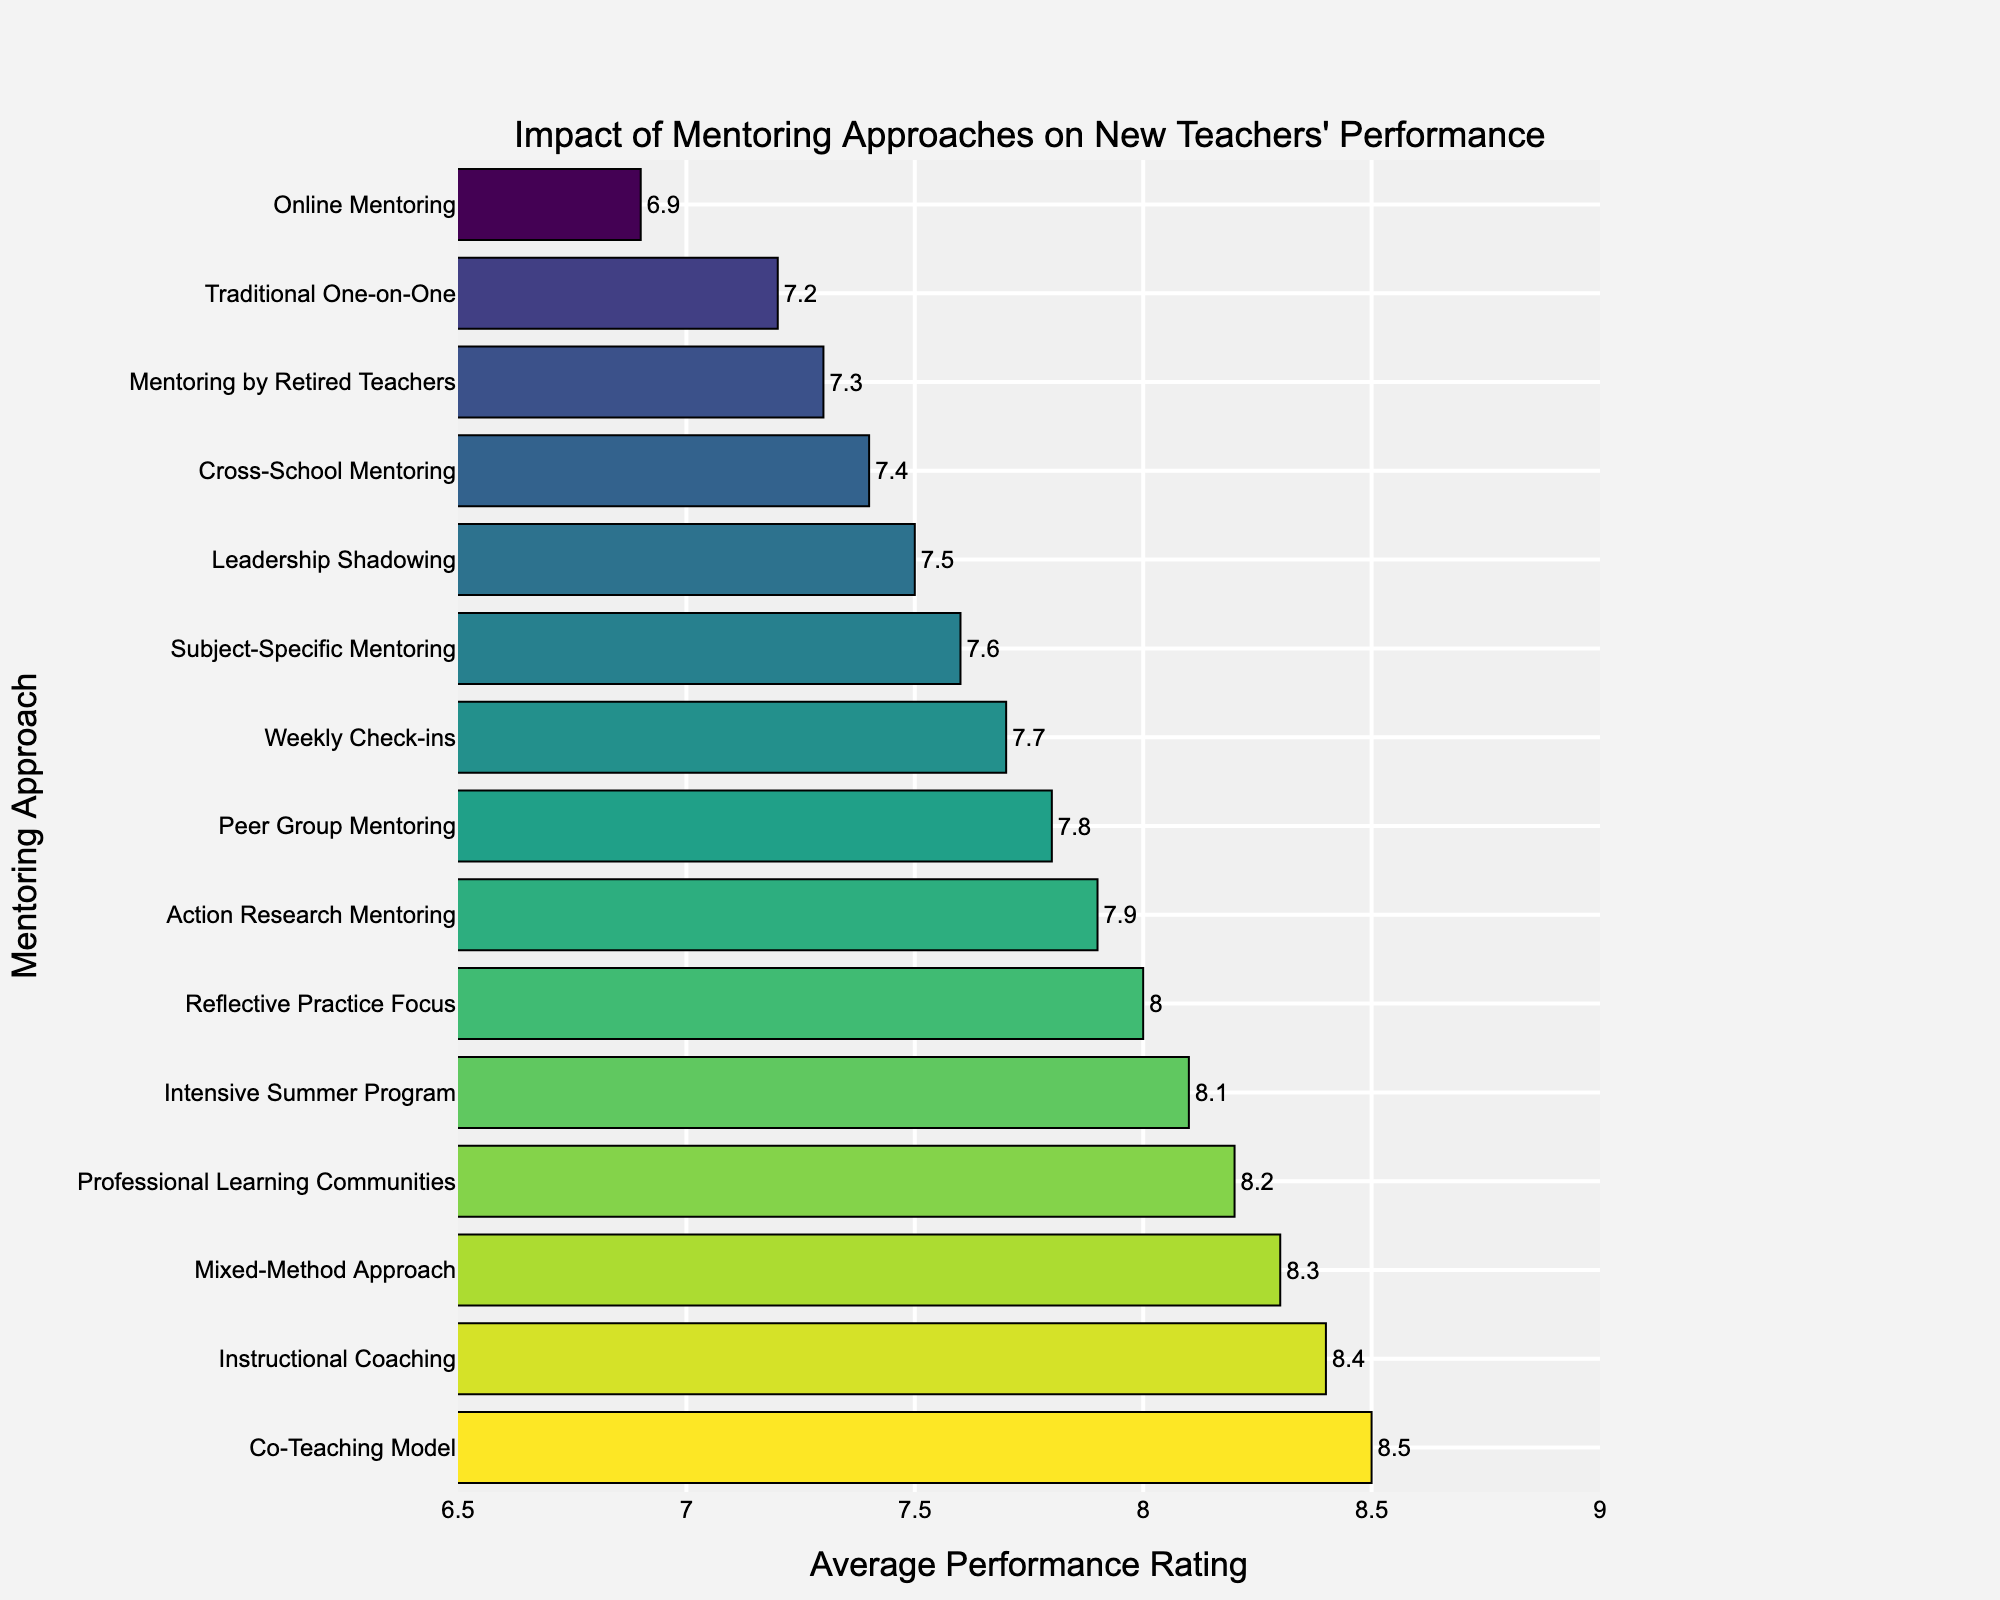Which mentoring approach has the highest average performance rating? The highest bar in the chart corresponds to the mentoring approach with the highest average performance rating. Identify this bar.
Answer: Co-Teaching Model What is the difference in average performance rating between the Co-Teaching Model and Online Mentoring? Find the bar heights for Co-Teaching Model (8.5) and Online Mentoring (6.9). Subtract the smaller from the larger rating.
Answer: 1.6 Which mentoring approaches have an average performance rating greater than 8.0? Look for the bars with heights above the 8.0 mark and list their corresponding mentoring approaches.
Answer: Mixed-Method Approach, Intensive Summer Program, Professional Learning Communities, Instructional Coaching, Co-Teaching Model How many mentoring approaches have an average performance rating less than 7.5? Count the number of bars that do not exceed the 7.5 mark.
Answer: Three What's the combined average performance rating of Instructional Coaching, Mixed-Method Approach, and Professional Learning Communities? Sum the performance ratings of the three approaches (8.4 + 8.3 + 8.2).
Answer: 24.9 Which mentoring approach appears visually midway down the sorted chart and what is its average performance rating? The midpoint in a sorted bar chart with 15 approaches is the 8th bar from the top. Identify this bar and its label.
Answer: Weekly Check-ins, 7.7 Is the average performance rating for Peer Group Mentoring higher, lower, or equal to Cross-School Mentoring? Compare the heights of the bars for Peer Group Mentoring (7.8) and Cross-School Mentoring (7.4).
Answer: Higher What is the total average performance rating of all categories? Sum the average performance ratings of all mentoring approaches.
Answer: 112.1 How does the average performance rating of Mentoring by Retired Teachers compare to the Reflective Practice Focus? Compare the heights of the bars for Mentoring by Retired Teachers (7.3) and Reflective Practice Focus (8.0).
Answer: Lower 